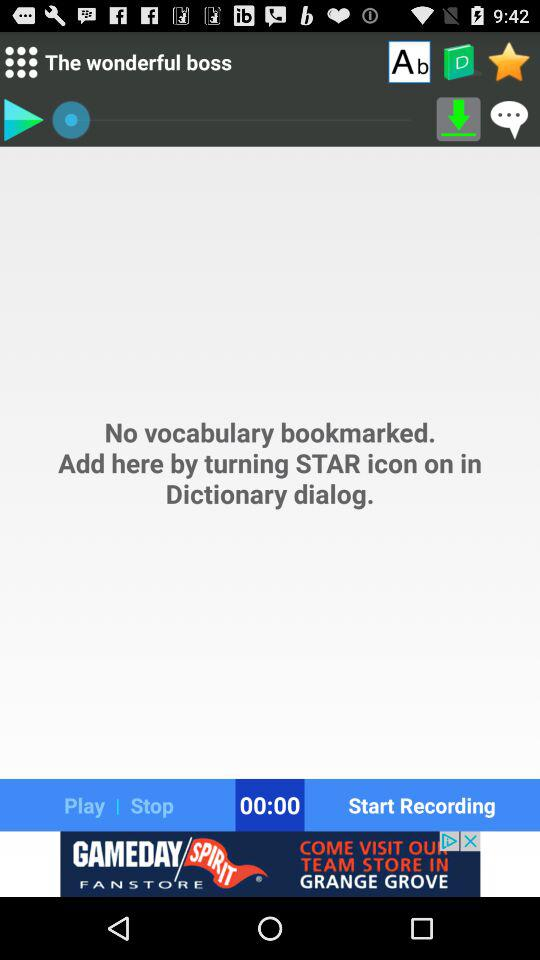Is there any vocabulary bookmarked? There is no vocabulary bookmarked. 